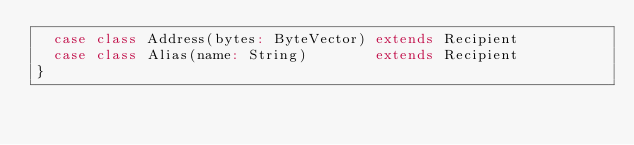<code> <loc_0><loc_0><loc_500><loc_500><_Scala_>  case class Address(bytes: ByteVector) extends Recipient
  case class Alias(name: String)        extends Recipient
}
</code> 